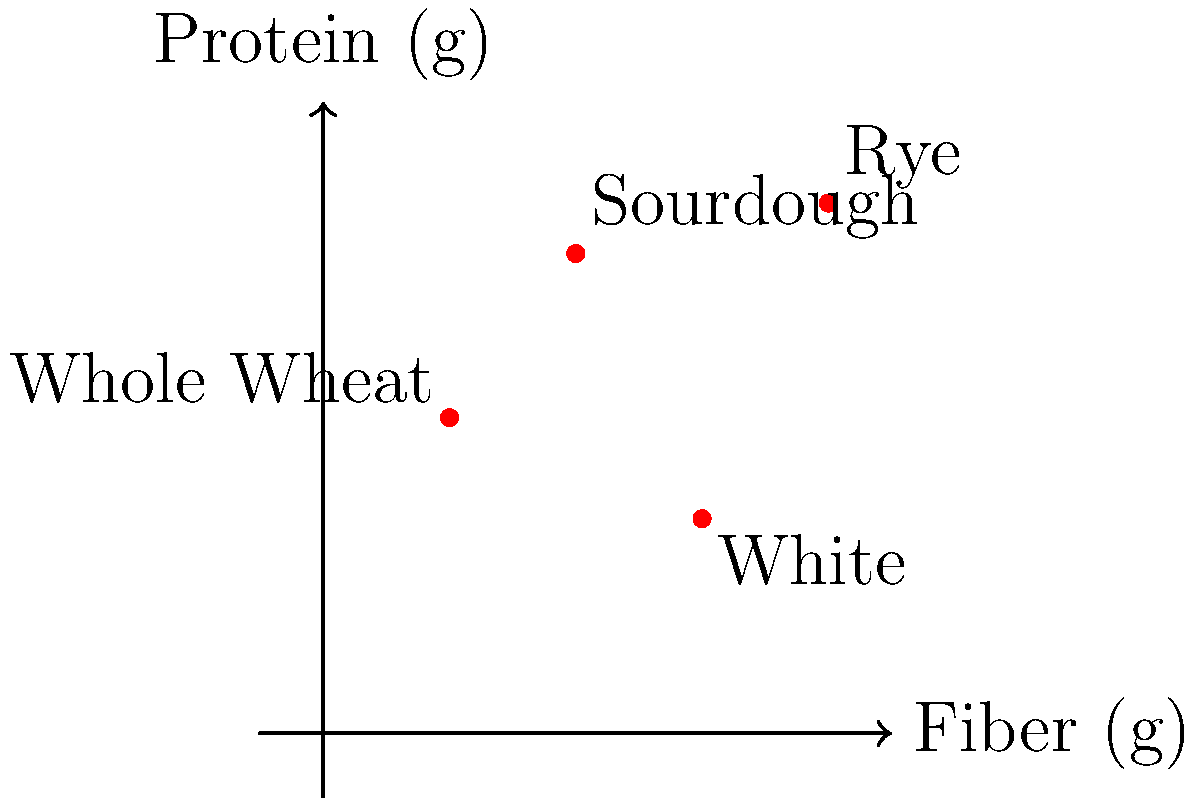As a nutritionist specializing in bakery trends, you're analyzing the nutritional content of different types of bread. The graph plots the fiber content (x-axis) against the protein content (y-axis) for four types of bread: Whole Wheat, Sourdough, White, and Rye. Based on the graph, which type of bread has the highest combined amount of fiber and protein per serving? To determine which bread has the highest combined amount of fiber and protein, we need to:

1. Identify the coordinates (fiber, protein) for each bread type:
   - Whole Wheat: (1, 2.5)
   - Sourdough: (2, 3.8)
   - White: (3, 1.7)
   - Rye: (4, 4.2)

2. Calculate the sum of fiber and protein for each bread:
   - Whole Wheat: 1 + 2.5 = 3.5
   - Sourdough: 2 + 3.8 = 5.8
   - White: 3 + 1.7 = 4.7
   - Rye: 4 + 4.2 = 8.2

3. Compare the sums:
   Rye bread has the highest combined amount at 8.2 grams per serving.

4. Verify visually:
   The Rye bread point is indeed the furthest from the origin when considering both x and y coordinates together.
Answer: Rye bread 